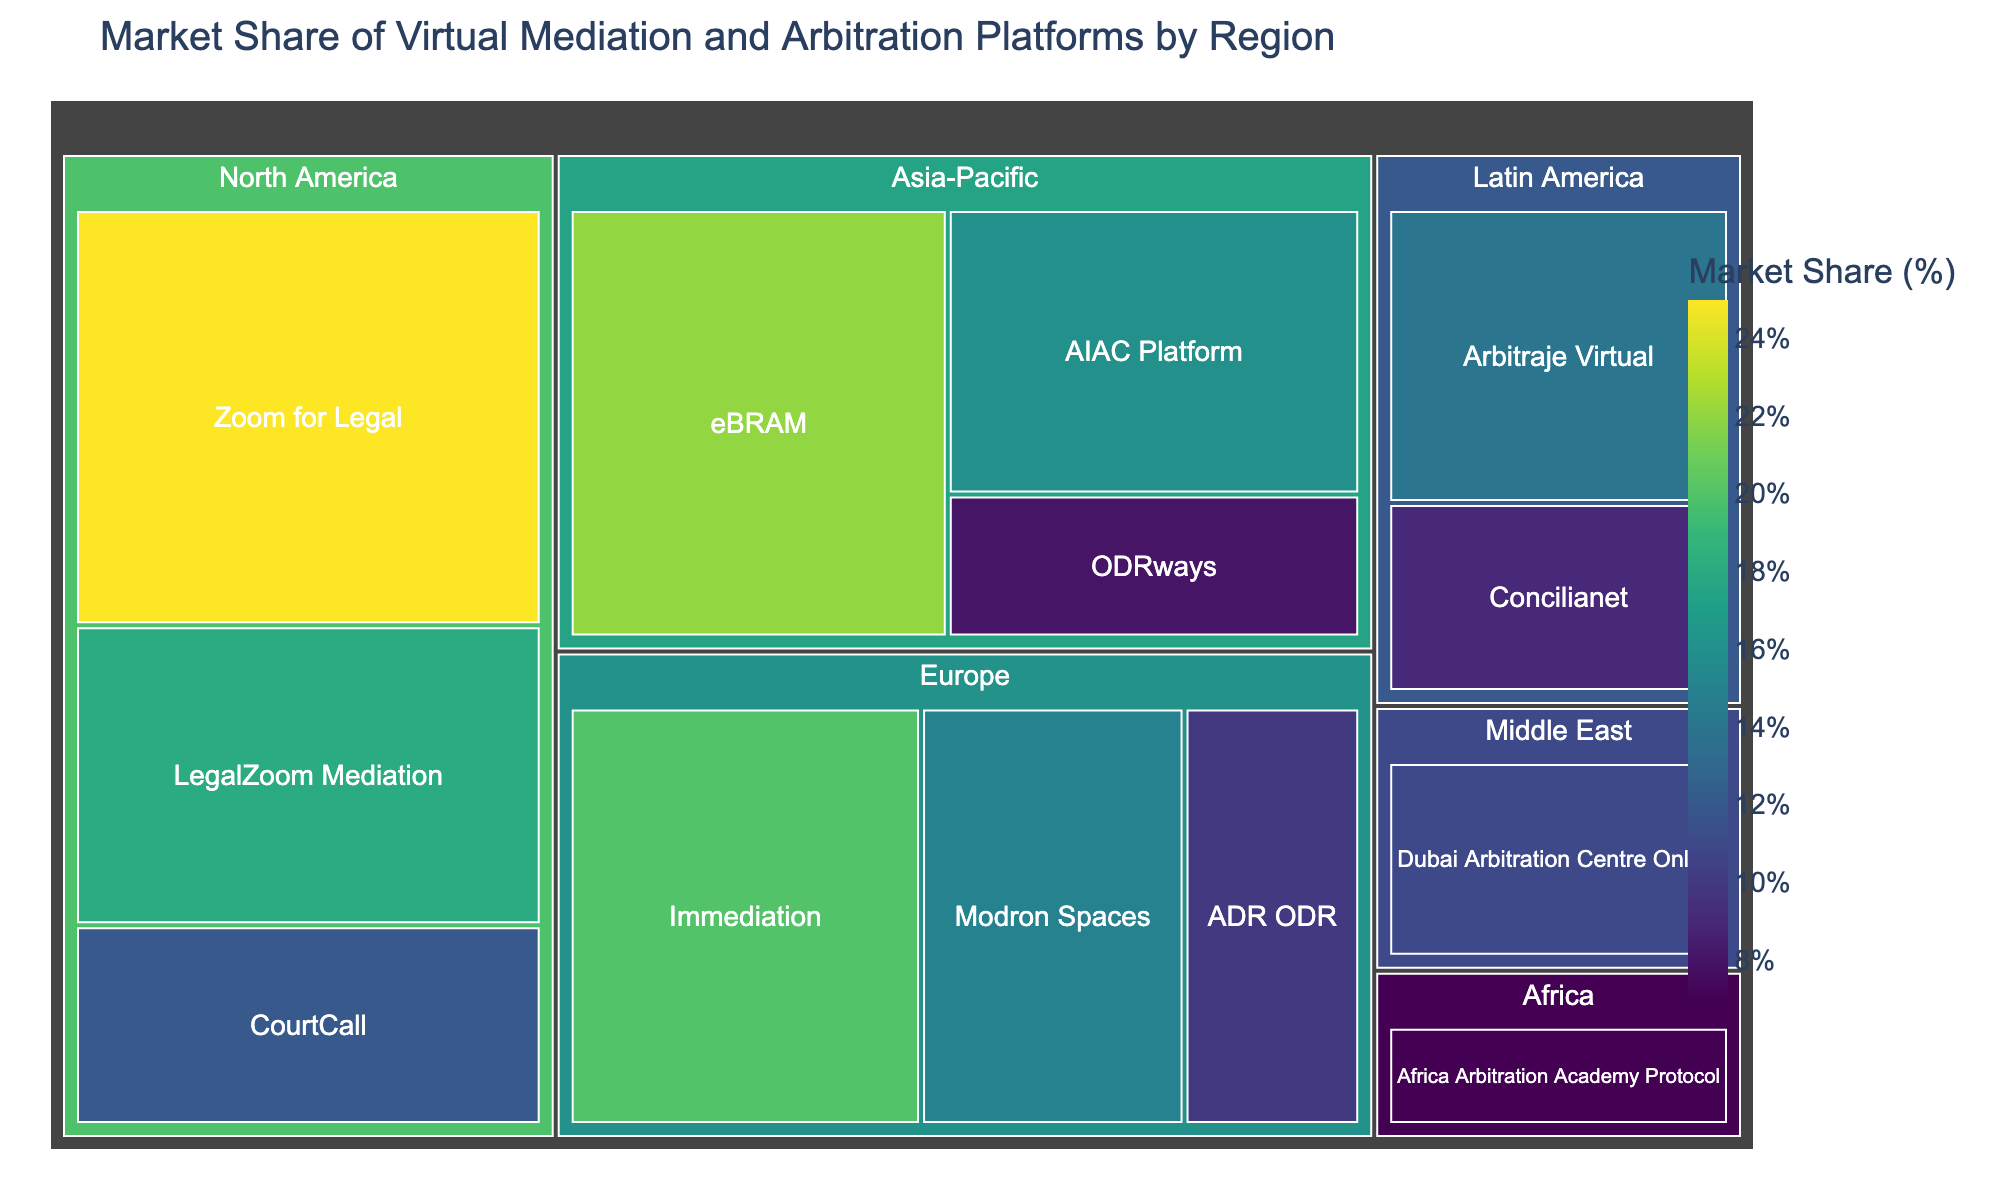What is the title of the figure? The title is usually displayed at the top of the figure. The figure title is "Market Share of Virtual Mediation and Arbitration Platforms by Region".
Answer: Market Share of Virtual Mediation and Arbitration Platforms by Region Which region has the platform with the highest market share? By looking at the relative size of the blocks, North America has Zoom for Legal with the largest block. The market share is 25%.
Answer: North America What is the market share of LegalZoom Mediation in North America? Locate the block for LegalZoom Mediation under the North America section. The value provided in the block is 18%.
Answer: 18% Which platform has the smallest market share in Europe? Under the Europe section, identify the smallest block. The platform ADR ODR has the smallest market share in Europe with 10%.
Answer: ADR ODR Compare the total market share of platforms in Asia-Pacific and Europe. Which region has a higher total market share? Sum the market share values for Asia-Pacific (22 + 16 + 8 = 46%) and Europe (20 + 15 + 10 = 45%). Compare the totals. Asia-Pacific has a higher total market share.
Answer: Asia-Pacific What is the combined market share of platforms in Latin America? Sum the market shares for Arbitraje Virtual and Concilianet in Latin America (14 + 9). The combined market share is 23%.
Answer: 23% Which region has the most diverse range of market shares among its platforms? Compare the range of market shares within each region. North America has market shares of 25%, 18%, and 12%, with a range of 13 (25-12). Europe has market shares of 20%, 15%, and 10%, with a range of 10. Asia-Pacific has market shares of 22%, 16%, and 8%, with a range of 14. Latin America has market shares of 14% and 9%, with a range of 5. Middle East and Africa each have just one platform. The Asia-Pacific region has the most diverse range.
Answer: Asia-Pacific What is the market share difference between Zoom for Legal and CourtCall in North America? Subtract the market share of CourtCall from that of Zoom for Legal (25 - 12). The difference is 13%.
Answer: 13% Which region has only one platform and what is its market share? Look for regions with only a single block. Both Middle East and Africa have one platform each. Dubai Arbitration Centre Online in the Middle East has 11%, and Africa Arbitration Academy Protocol in Africa has 7%. The regions are Middle East and Africa with 11% and 7%, respectively.
Answer: Middle East (11%); Africa (7%) How does the market share of eBRAM in Asia-Pacific compare to that of Immediation in Europe? eBRAM has a market share of 22% in Asia-Pacific, while Immediation has a market share of 20% in Europe. eBRAM has a 2% higher market share than Immediation.
Answer: eBRAM has a 2% higher market share 